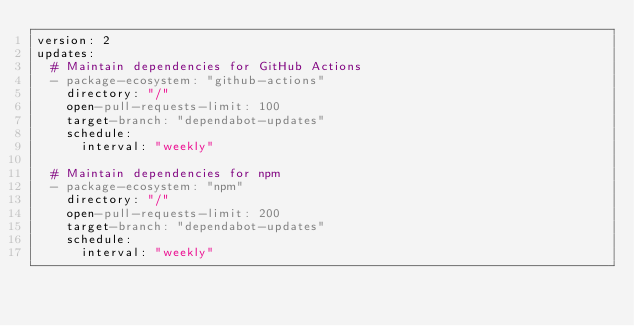Convert code to text. <code><loc_0><loc_0><loc_500><loc_500><_YAML_>version: 2
updates:
  # Maintain dependencies for GitHub Actions
  - package-ecosystem: "github-actions"
    directory: "/"
    open-pull-requests-limit: 100
    target-branch: "dependabot-updates"
    schedule:
      interval: "weekly"

  # Maintain dependencies for npm
  - package-ecosystem: "npm"
    directory: "/"
    open-pull-requests-limit: 200
    target-branch: "dependabot-updates"
    schedule:
      interval: "weekly"
</code> 